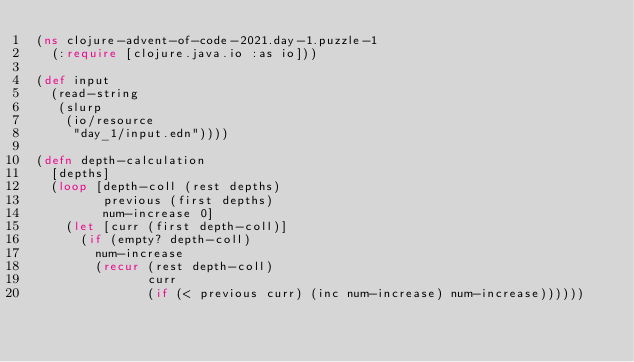<code> <loc_0><loc_0><loc_500><loc_500><_Clojure_>(ns clojure-advent-of-code-2021.day-1.puzzle-1
  (:require [clojure.java.io :as io]))

(def input
  (read-string
   (slurp
    (io/resource 
     "day_1/input.edn"))))

(defn depth-calculation
  [depths]
  (loop [depth-coll (rest depths)
         previous (first depths)
         num-increase 0] 
    (let [curr (first depth-coll)]
      (if (empty? depth-coll)
        num-increase
        (recur (rest depth-coll)
               curr
               (if (< previous curr) (inc num-increase) num-increase))))))
</code> 